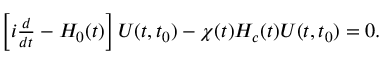<formula> <loc_0><loc_0><loc_500><loc_500>\begin{array} { r } { \left [ i \frac { d } { d t } - H _ { 0 } ( t ) \right ] U ( t , t _ { 0 } ) - \chi ( t ) H _ { c } ( t ) U ( t , t _ { 0 } ) = 0 . } \end{array}</formula> 